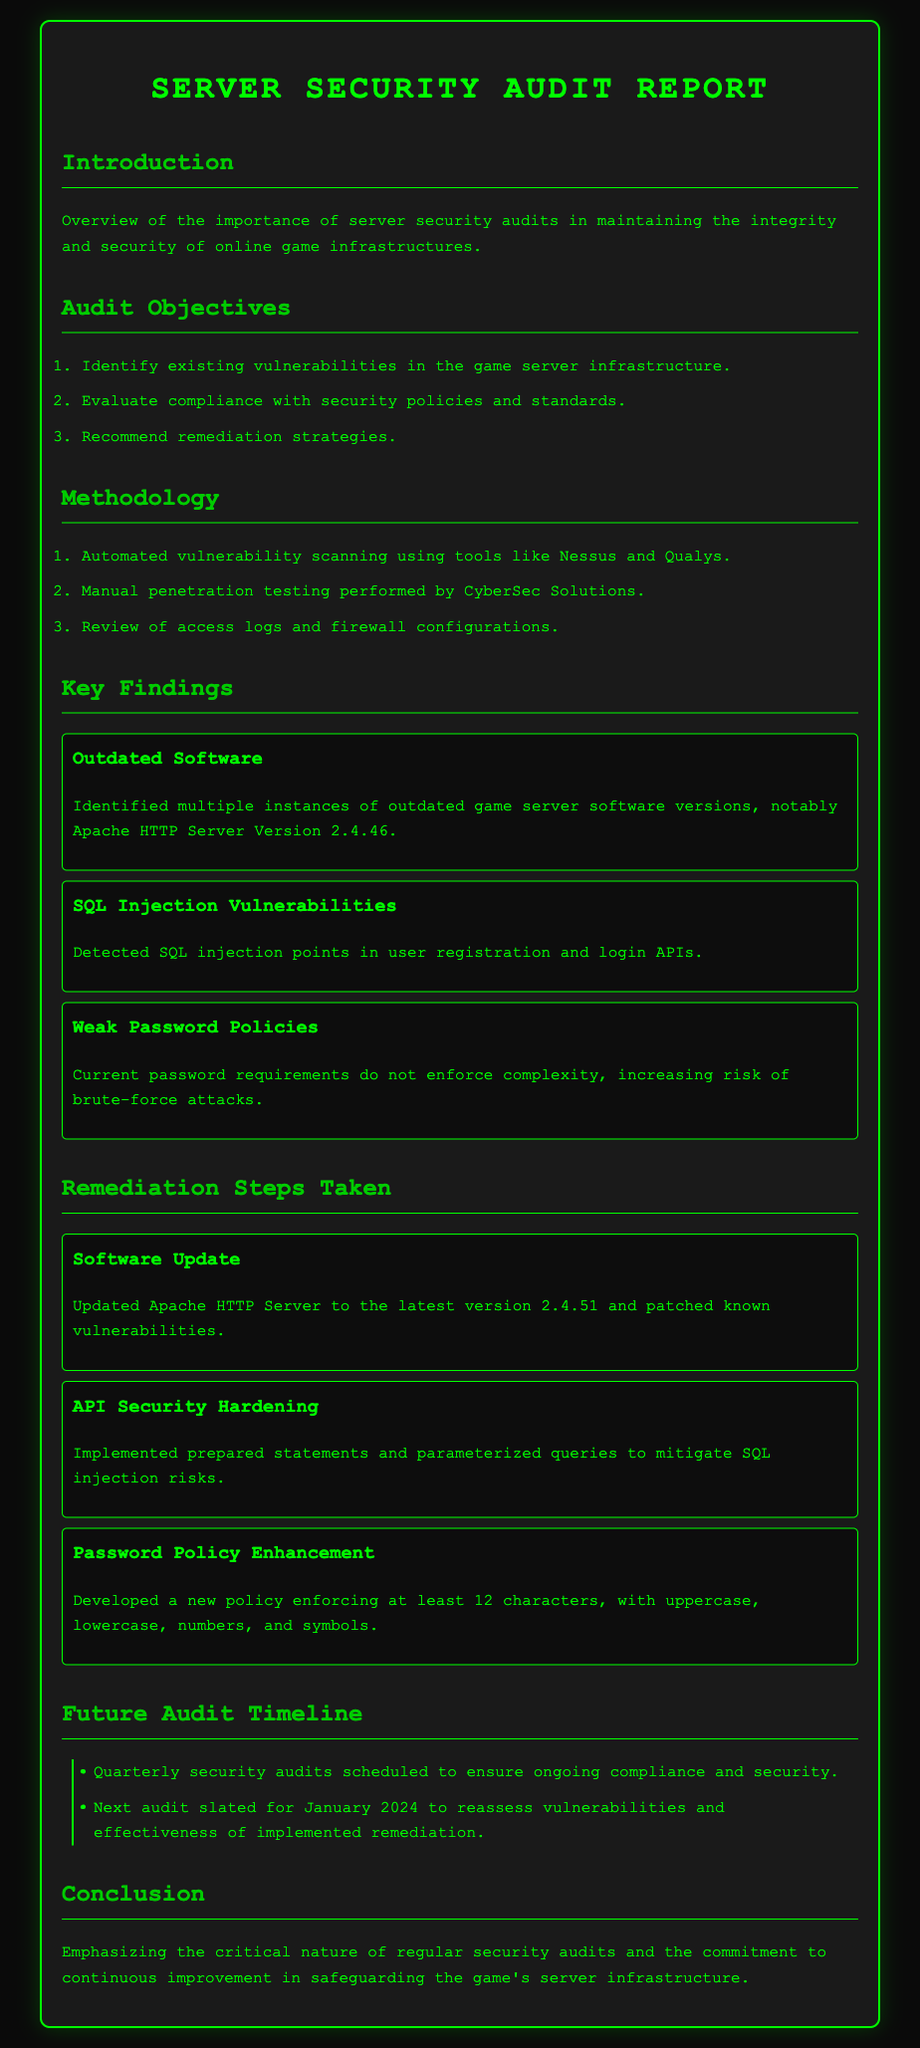What are the audit objectives? The audit objectives listed in the document are to identify existing vulnerabilities, evaluate compliance, and recommend remediation strategies.
Answer: Identify existing vulnerabilities, evaluate compliance with security policies and standards, recommend remediation strategies What was found to be outdated in the audit? The document highlights that multiple instances of outdated game server software were identified, specifically mentioning the Apache HTTP Server.
Answer: Outdated game server software How often are security audits scheduled? The timeline section of the document specifies that security audits are scheduled quarterly.
Answer: Quarterly What is the next audit date? According to the future audit timeline, the next audit is slated for January 2024.
Answer: January 2024 What was implemented to mitigate SQL injection risks? The document states that prepared statements and parameterized queries were implemented for API security hardening.
Answer: Prepared statements and parameterized queries What character length is enforced in the new password policy? The password policy enhancement specifies that at least 12 characters must be enforced.
Answer: 12 characters Which tool was used for automated vulnerability scanning? The methodology mentions that tools like Nessus and Qualys were used for automated vulnerability scanning.
Answer: Nessus and Qualys Who conducted the manual penetration testing? The manual penetration testing was performed by CyberSec Solutions, as mentioned in the methodology section.
Answer: CyberSec Solutions 